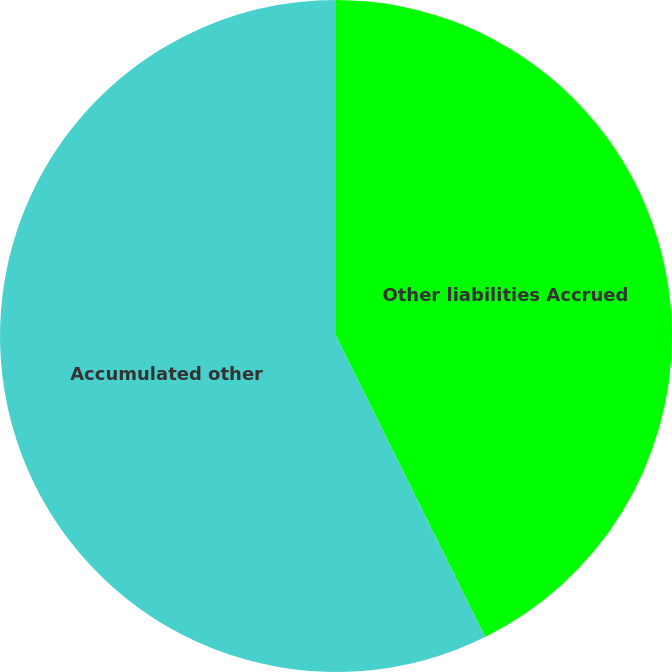<chart> <loc_0><loc_0><loc_500><loc_500><pie_chart><fcel>Other liabilities Accrued<fcel>Accumulated other<nl><fcel>42.68%<fcel>57.32%<nl></chart> 